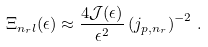<formula> <loc_0><loc_0><loc_500><loc_500>\Xi _ { n _ { r } l } ( \epsilon ) \approx \frac { 4 { \mathcal { J } } ( \epsilon ) } { \epsilon ^ { 2 } } \left ( j _ { p , n _ { r } } \right ) ^ { - 2 } \, .</formula> 